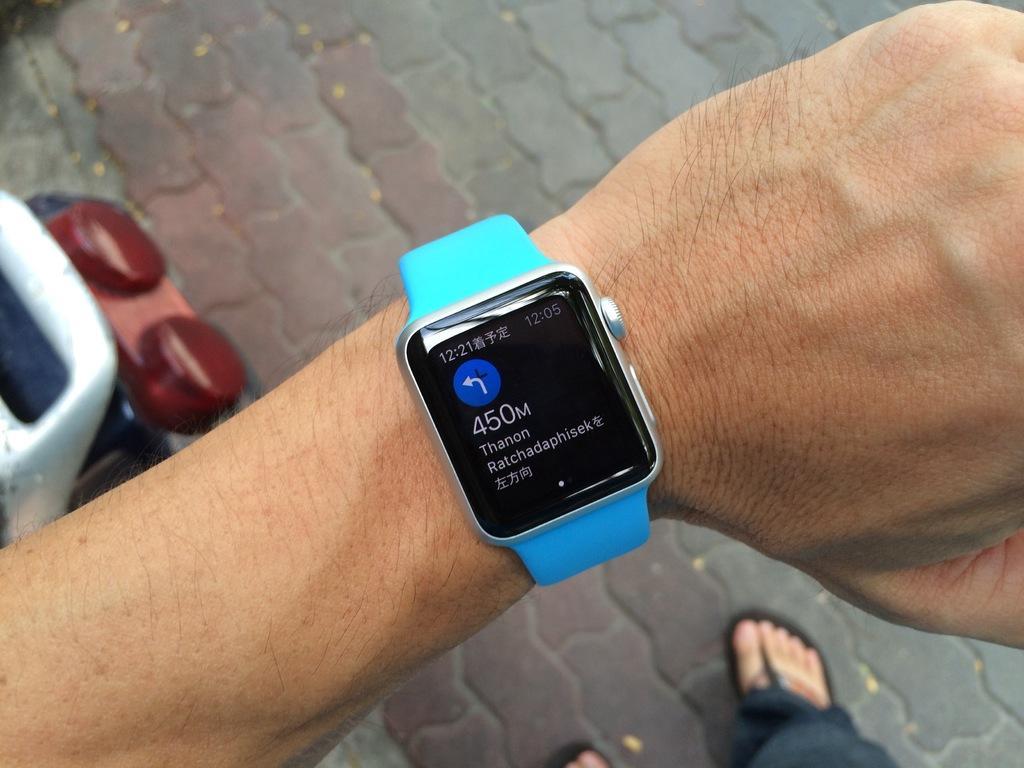Describe this image in one or two sentences. In this picture we can see a person hand wore a watch and below this hand we can see an object and legs on the floor. 